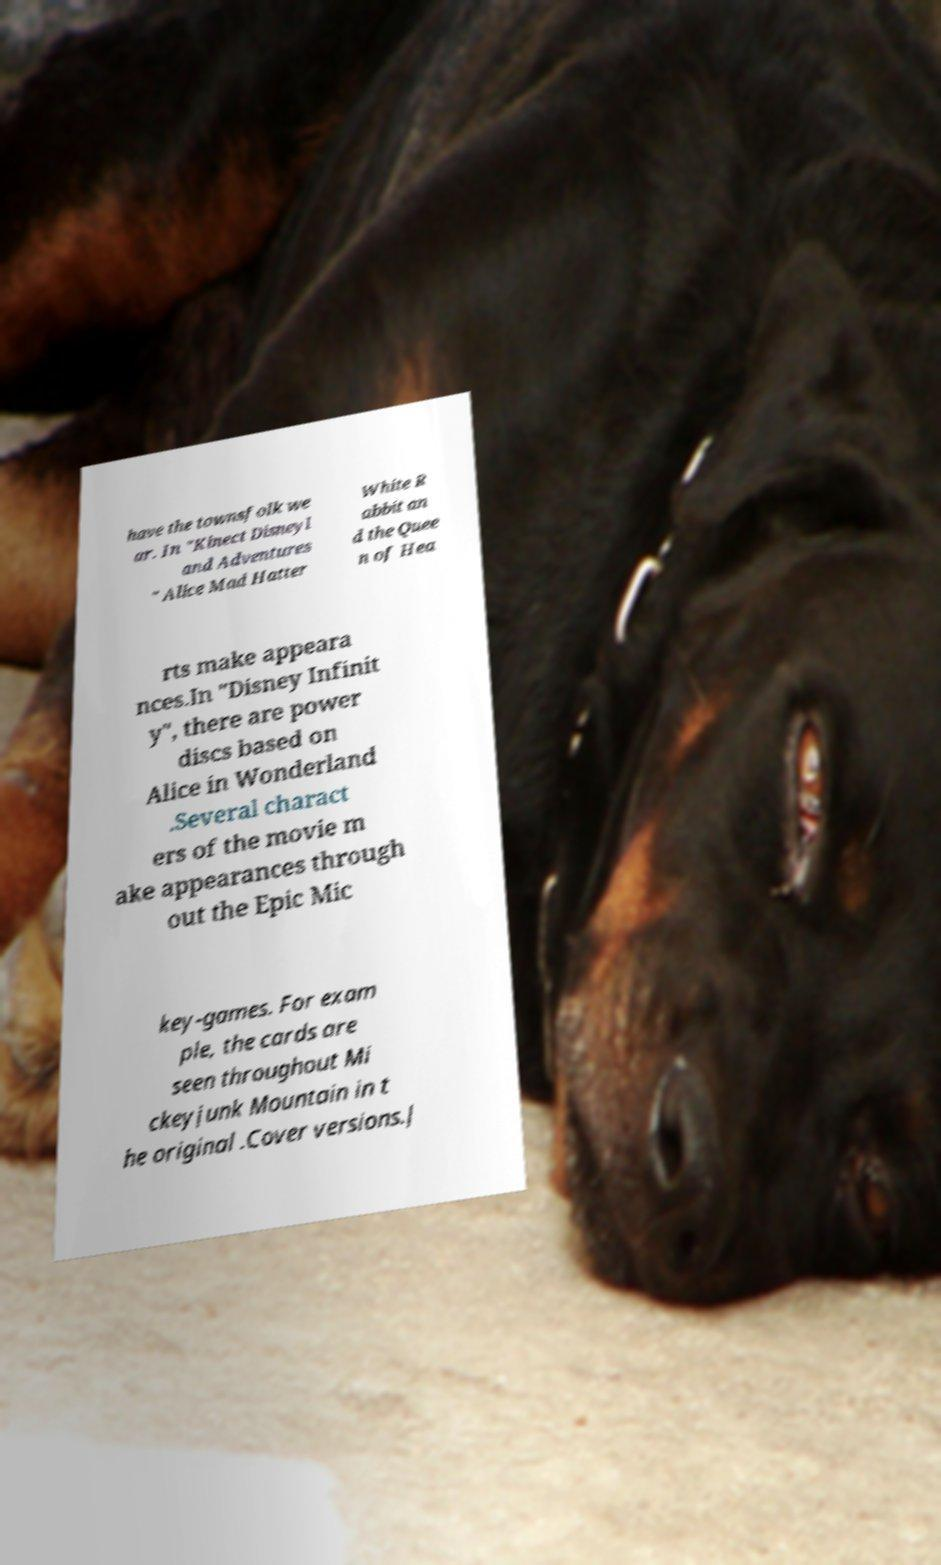I need the written content from this picture converted into text. Can you do that? have the townsfolk we ar. In "Kinect Disneyl and Adventures " Alice Mad Hatter White R abbit an d the Quee n of Hea rts make appeara nces.In "Disney Infinit y", there are power discs based on Alice in Wonderland .Several charact ers of the movie m ake appearances through out the Epic Mic key-games. For exam ple, the cards are seen throughout Mi ckeyjunk Mountain in t he original .Cover versions.J 